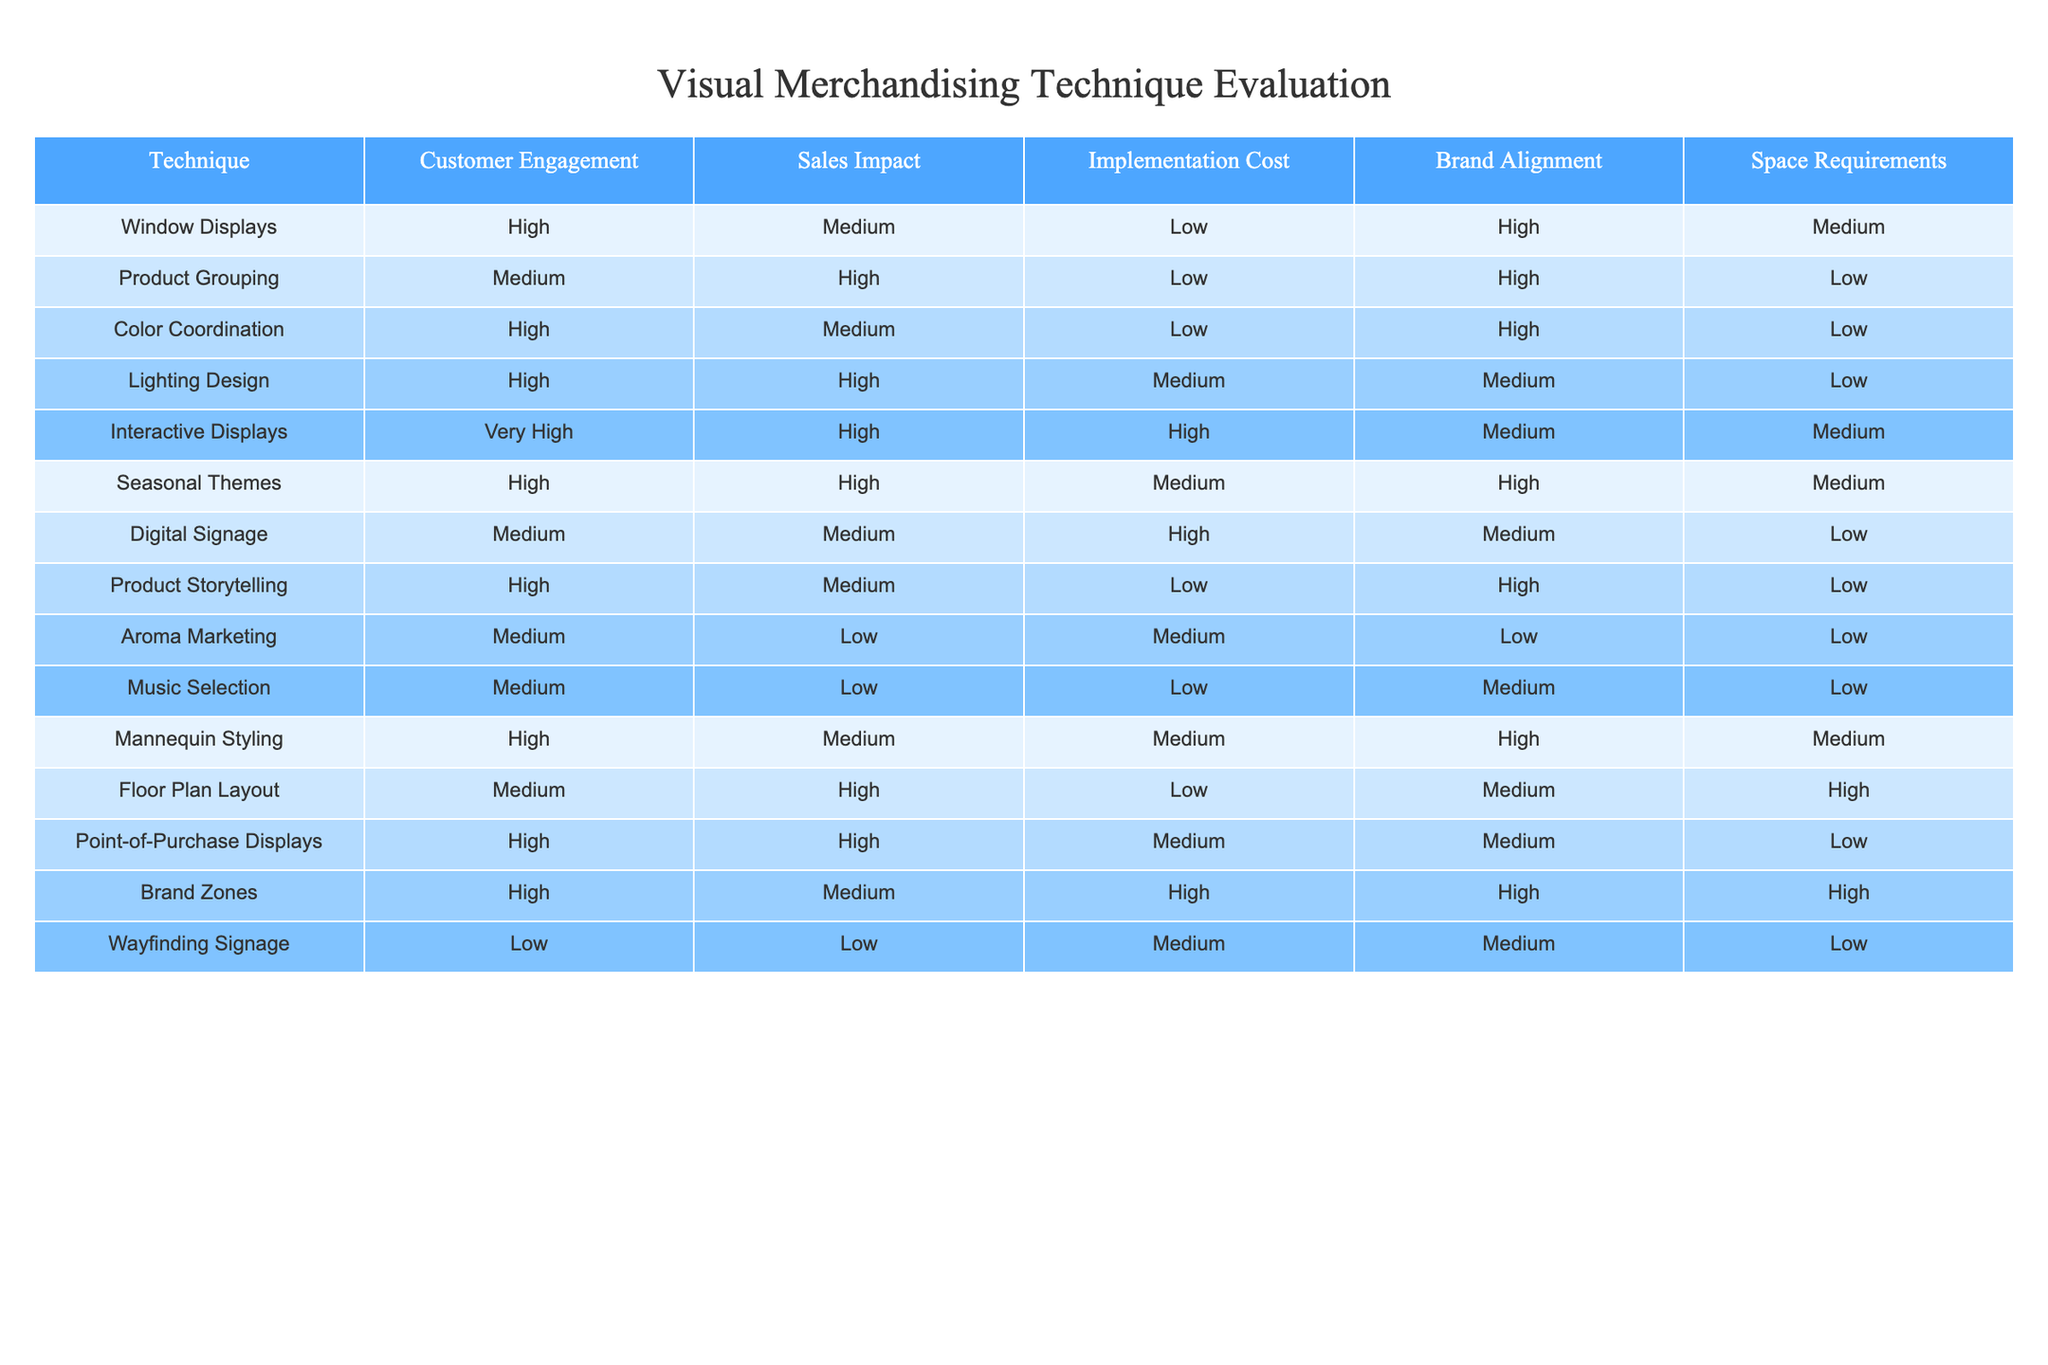What technique has the highest customer engagement? From the table, the technique "Interactive Displays" has the highest customer engagement rating of "Very High".
Answer: Interactive Displays Which technique has a medium implementation cost but high sales impact? By examining the table, "Point-of-Purchase Displays" is the only technique that fits these criteria, with a medium implementation cost and high sales impact.
Answer: Point-of-Purchase Displays Is "Aroma Marketing" aligned with the brand? The table indicates that "Aroma Marketing" has a brand alignment rating of "Low". Therefore, it is not aligned with the brand.
Answer: No What is the total number of techniques that have high customer engagement and are high in sales impact? Upon reviewing the table, the techniques include "Interactive Displays", "Lighting Design", "Seasonal Themes", and "Point-of-Purchase Displays". Counting these gives a total of 4 techniques.
Answer: 4 How many techniques have low space requirements? The table lists three techniques that have low space requirements: "Product Grouping", "Color Coordination", "Digital Signage", and "Aroma Marketing". Therefore, the total count is 4.
Answer: 4 Is there any technique that has both high customer engagement and medium implementation cost? Analyzing the table, "Mannequin Styling" meets this criterion, as it has high customer engagement and medium implementation cost.
Answer: Yes What is the average customer engagement rating of all techniques? The customer engagement ratings are: High (5), Medium (5), Very High (1), and Low (2). Assign numerical values: Very High (4), High (3), Medium (2), Low (1). The sum is: (5*3) + (5*2) + (1*4) + (2*1) = 15 + 10 + 4 + 2 = 31 across 12 techniques, so the average is 31/12 = 2.58.
Answer: 2.58 Which techniques have high brand alignment but high implementation cost? Reviewing the table, "Brand Zones" is the only technique that has high brand alignment and also comes with a high implementation cost.
Answer: Brand Zones Are there any techniques with low sales impact? "Aroma Marketing" and "Wayfinding Signage" both exhibit a sales impact rating of "Low". Therefore, there are two techniques that fit this category.
Answer: Yes 